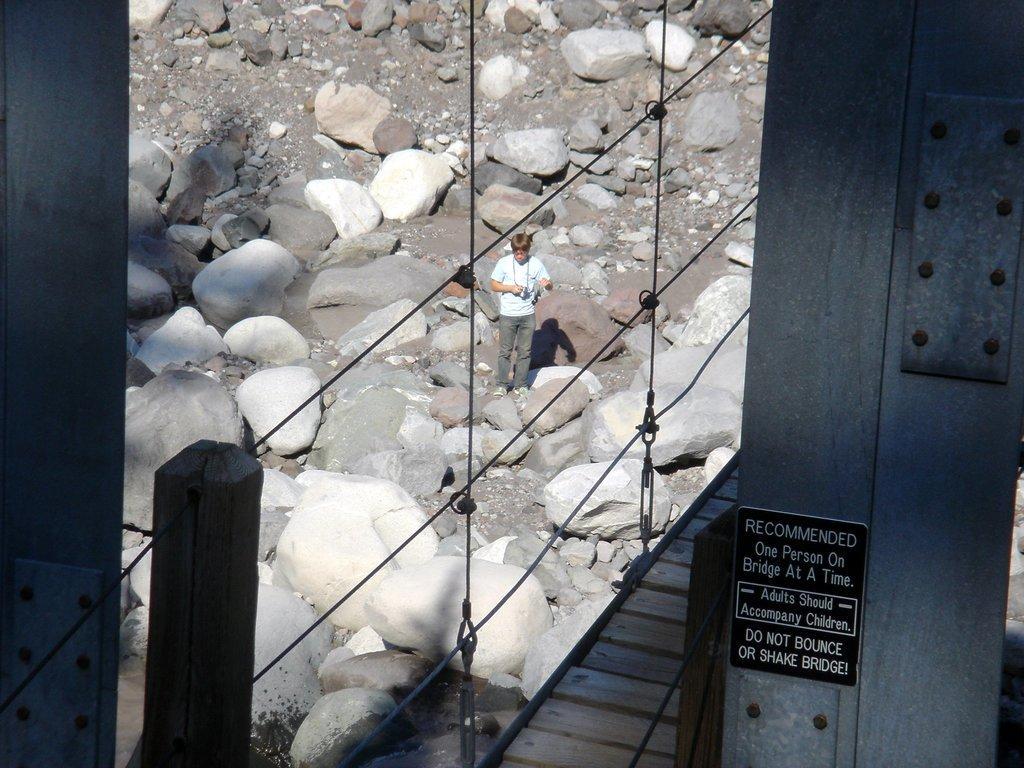Can you describe this image briefly? The man in the middle of the picture wearing white t-shirt is holding a camera in his hands and beside him, we see rocks. On the right corner of the picture, we see a wall on which a black board with text written on it is placed. In the left bottom of the picture, we see a pole and the wires. 